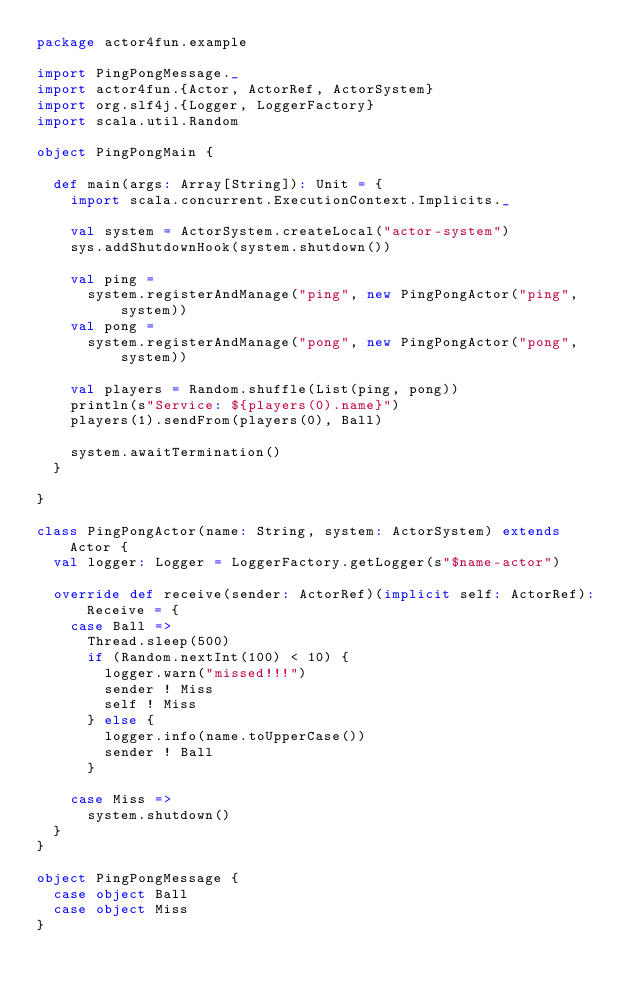<code> <loc_0><loc_0><loc_500><loc_500><_Scala_>package actor4fun.example

import PingPongMessage._
import actor4fun.{Actor, ActorRef, ActorSystem}
import org.slf4j.{Logger, LoggerFactory}
import scala.util.Random

object PingPongMain {

  def main(args: Array[String]): Unit = {
    import scala.concurrent.ExecutionContext.Implicits._

    val system = ActorSystem.createLocal("actor-system")
    sys.addShutdownHook(system.shutdown())

    val ping =
      system.registerAndManage("ping", new PingPongActor("ping", system))
    val pong =
      system.registerAndManage("pong", new PingPongActor("pong", system))

    val players = Random.shuffle(List(ping, pong))
    println(s"Service: ${players(0).name}")
    players(1).sendFrom(players(0), Ball)

    system.awaitTermination()
  }

}

class PingPongActor(name: String, system: ActorSystem) extends Actor {
  val logger: Logger = LoggerFactory.getLogger(s"$name-actor")

  override def receive(sender: ActorRef)(implicit self: ActorRef): Receive = {
    case Ball =>
      Thread.sleep(500)
      if (Random.nextInt(100) < 10) {
        logger.warn("missed!!!")
        sender ! Miss
        self ! Miss
      } else {
        logger.info(name.toUpperCase())
        sender ! Ball
      }

    case Miss =>
      system.shutdown()
  }
}

object PingPongMessage {
  case object Ball
  case object Miss
}
</code> 